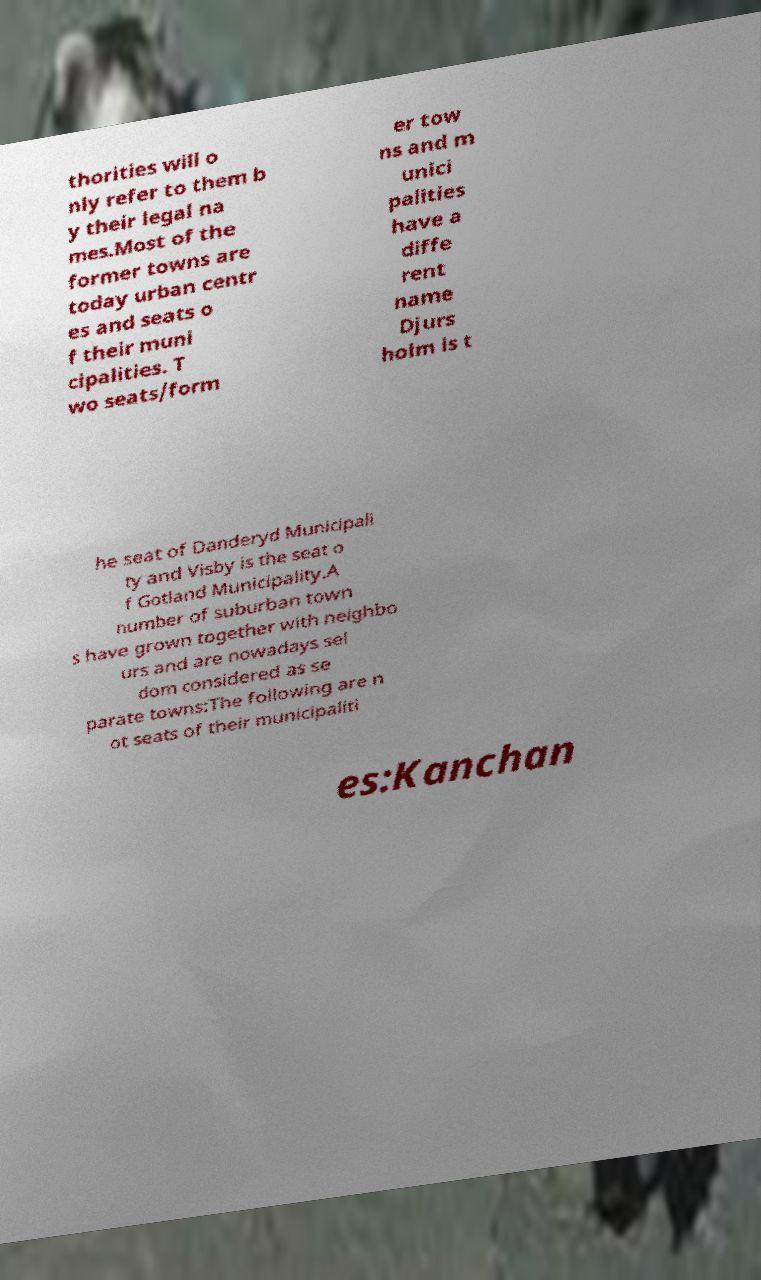What messages or text are displayed in this image? I need them in a readable, typed format. thorities will o nly refer to them b y their legal na mes.Most of the former towns are today urban centr es and seats o f their muni cipalities. T wo seats/form er tow ns and m unici palities have a diffe rent name Djurs holm is t he seat of Danderyd Municipali ty and Visby is the seat o f Gotland Municipality.A number of suburban town s have grown together with neighbo urs and are nowadays sel dom considered as se parate towns:The following are n ot seats of their municipaliti es:Kanchan 